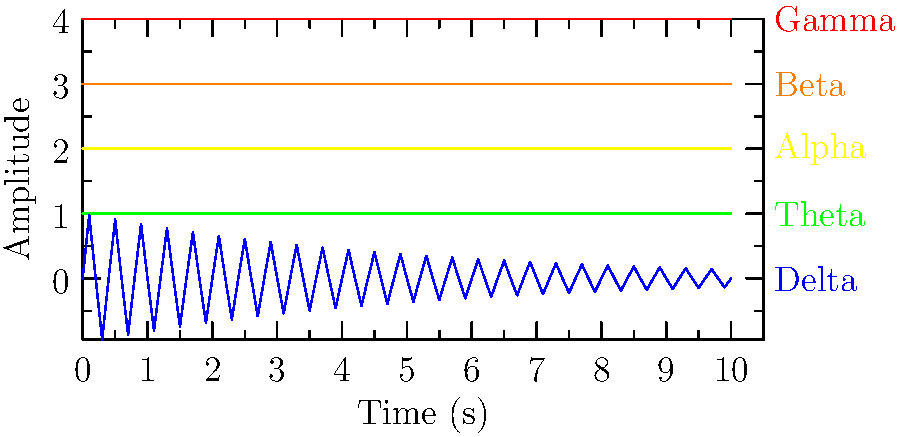Based on the graph showing different brain wave patterns, which type of brain wave has the highest frequency and is associated with heightened mental activity and information processing? To answer this question, we need to analyze the different brain wave patterns shown in the graph:

1. The graph displays five types of brain waves: Gamma, Beta, Alpha, Theta, and Delta.

2. Each wave is represented by a different color and labeled on the right side of the graph.

3. The x-axis represents time (in seconds), while the y-axis represents amplitude.

4. The frequency of each wave can be determined by observing how many cycles occur within a given time period.

5. Comparing the waves:
   - Gamma (red): Has the highest frequency, with the most cycles per second.
   - Beta (orange): Second highest frequency.
   - Alpha (yellow): Medium frequency.
   - Theta (green): Low frequency.
   - Delta (blue): Lowest frequency, with the fewest cycles per second.

6. In neuroscience, it's known that:
   - Gamma waves (30-100 Hz) are associated with heightened mental activity, information processing, and cognitive functioning.
   - Beta waves (13-30 Hz) are linked to normal waking consciousness and active thinking.
   - Alpha waves (8-13 Hz) are present during relaxed wakefulness.
   - Theta waves (4-8 Hz) occur during light sleep or deep meditation.
   - Delta waves (0.5-4 Hz) are predominant during deep sleep.

7. Based on this information, we can conclude that the brain wave with the highest frequency and associated with heightened mental activity and information processing is the Gamma wave.
Answer: Gamma waves 